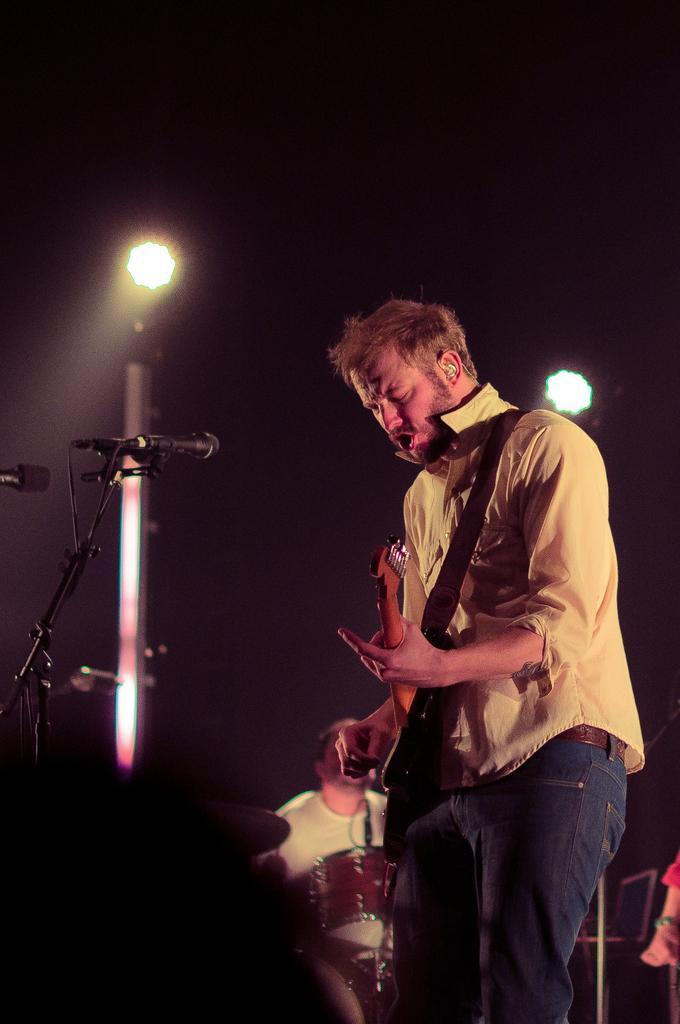Please provide a concise description of this image. In this image I can see a person standing in-front of the mic and holding the guitar. In the background there are lights and the person sitting. 